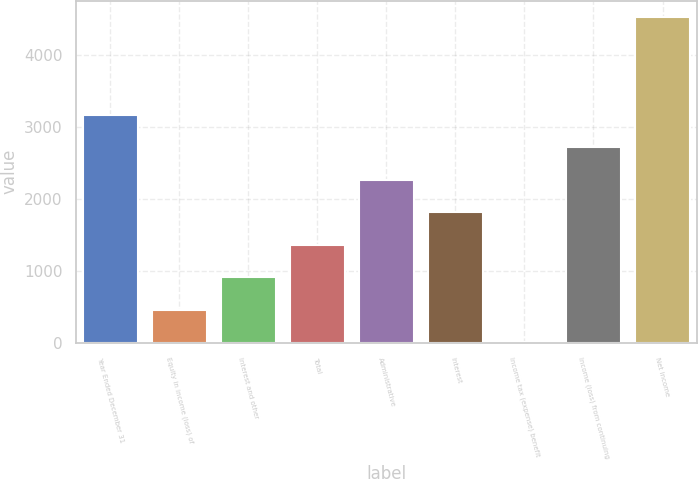Convert chart to OTSL. <chart><loc_0><loc_0><loc_500><loc_500><bar_chart><fcel>Year Ended December 31<fcel>Equity in income (loss) of<fcel>Interest and other<fcel>Total<fcel>Administrative<fcel>Interest<fcel>Income tax (expense) benefit<fcel>Income (loss) from continuing<fcel>Net income<nl><fcel>3173.4<fcel>460.2<fcel>912.4<fcel>1364.6<fcel>2269<fcel>1816.8<fcel>8<fcel>2721.2<fcel>4530<nl></chart> 